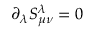<formula> <loc_0><loc_0><loc_500><loc_500>{ \partial } _ { \lambda } S _ { { \mu } { \nu } } ^ { \lambda } = 0</formula> 